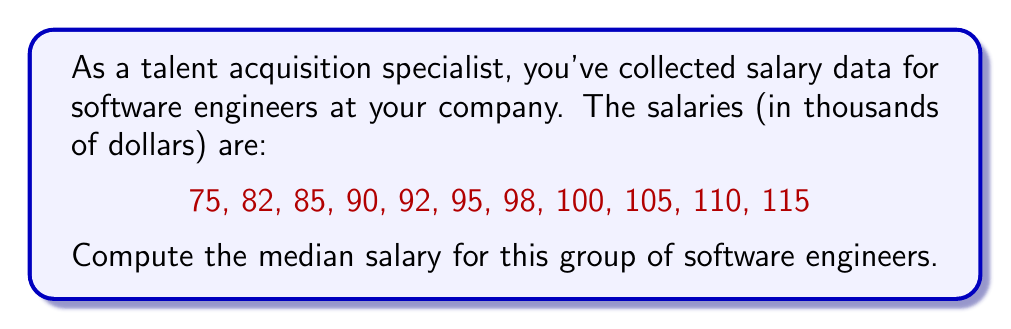Can you answer this question? To find the median salary, we need to follow these steps:

1. First, we need to arrange the data in ascending order:
   75, 82, 85, 90, 92, 95, 98, 100, 105, 110, 115

2. Count the total number of data points:
   $n = 11$

3. Since $n$ is odd, the median will be the middle value. We can find the position of the median using the formula:

   $\text{Median position} = \frac{n + 1}{2} = \frac{11 + 1}{2} = 6$

4. The 6th value in our ordered list is the median.

5. Counting to the 6th position, we find that the median salary is 95 thousand dollars.

This method works because the median is the middle value in a sorted list when the number of items is odd. It represents the central tendency of the data and is useful in salary negotiations as it's less affected by extreme values compared to the mean.
Answer: The median salary for software engineers in this group is $95,000. 